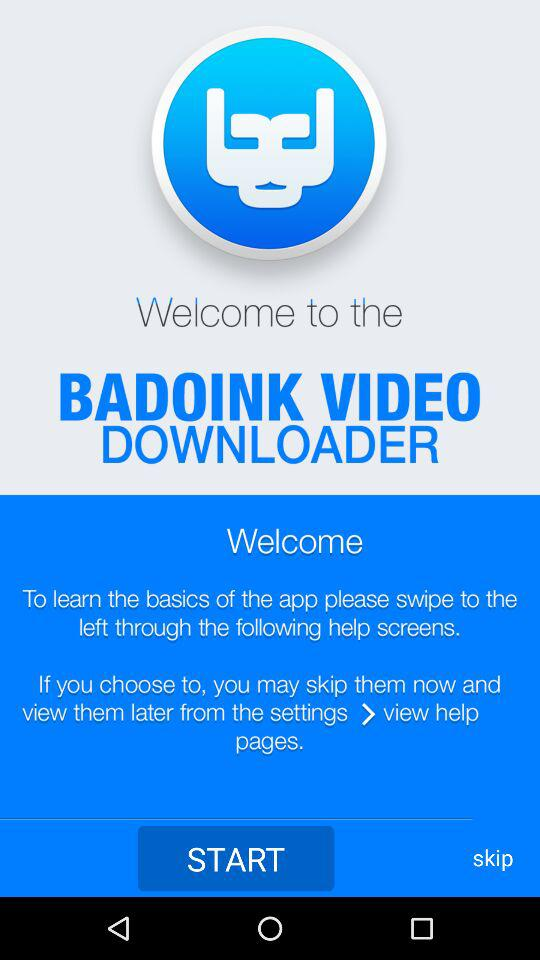What is the application name? The application name is "BADOINK VIDEO DOWNLOADER". 